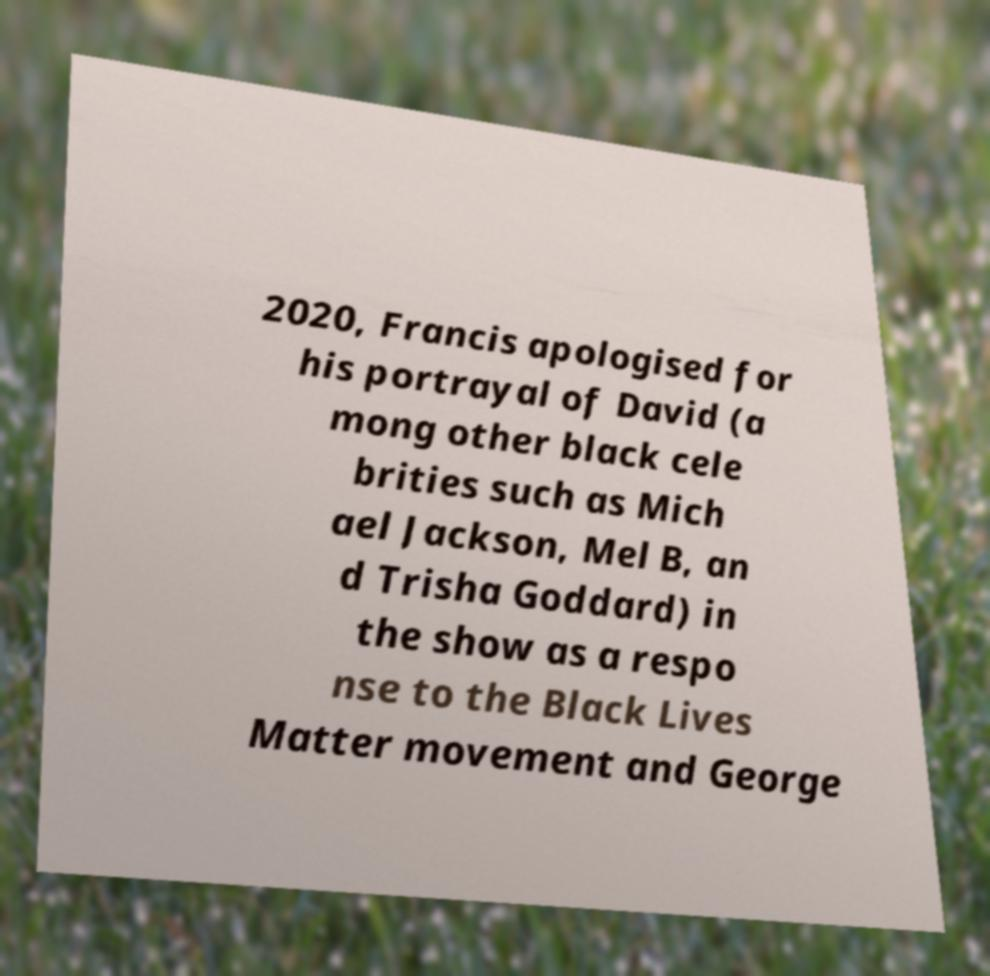There's text embedded in this image that I need extracted. Can you transcribe it verbatim? 2020, Francis apologised for his portrayal of David (a mong other black cele brities such as Mich ael Jackson, Mel B, an d Trisha Goddard) in the show as a respo nse to the Black Lives Matter movement and George 